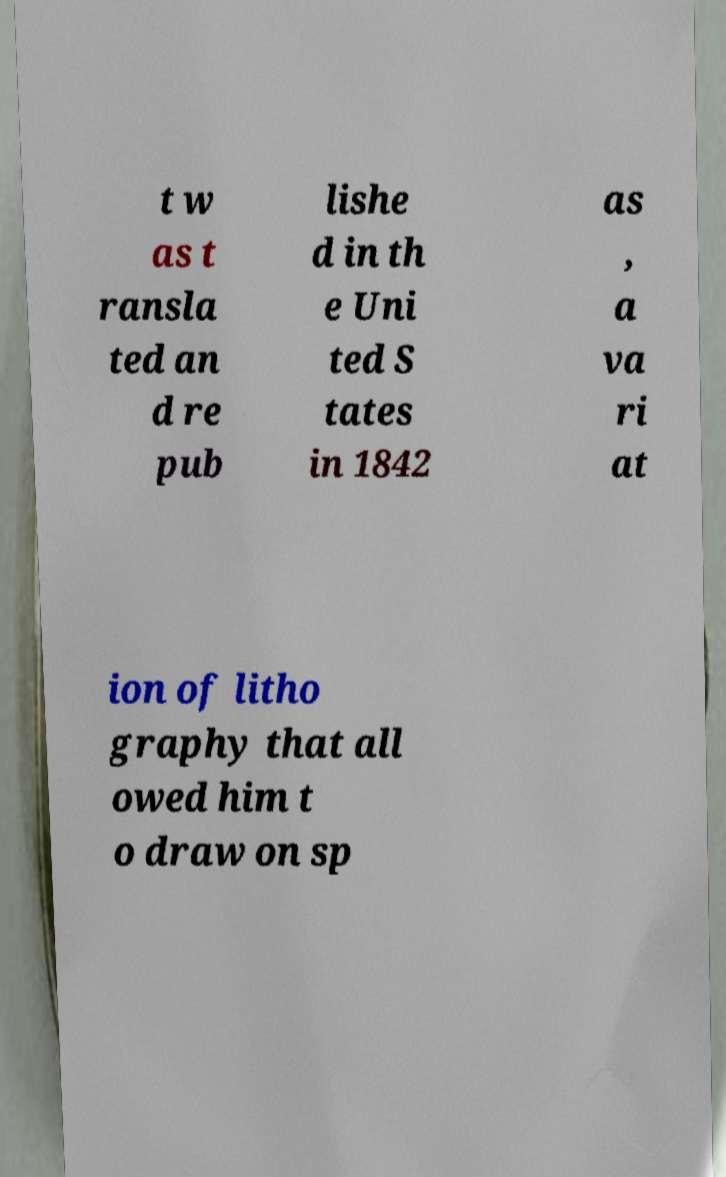Please identify and transcribe the text found in this image. t w as t ransla ted an d re pub lishe d in th e Uni ted S tates in 1842 as , a va ri at ion of litho graphy that all owed him t o draw on sp 